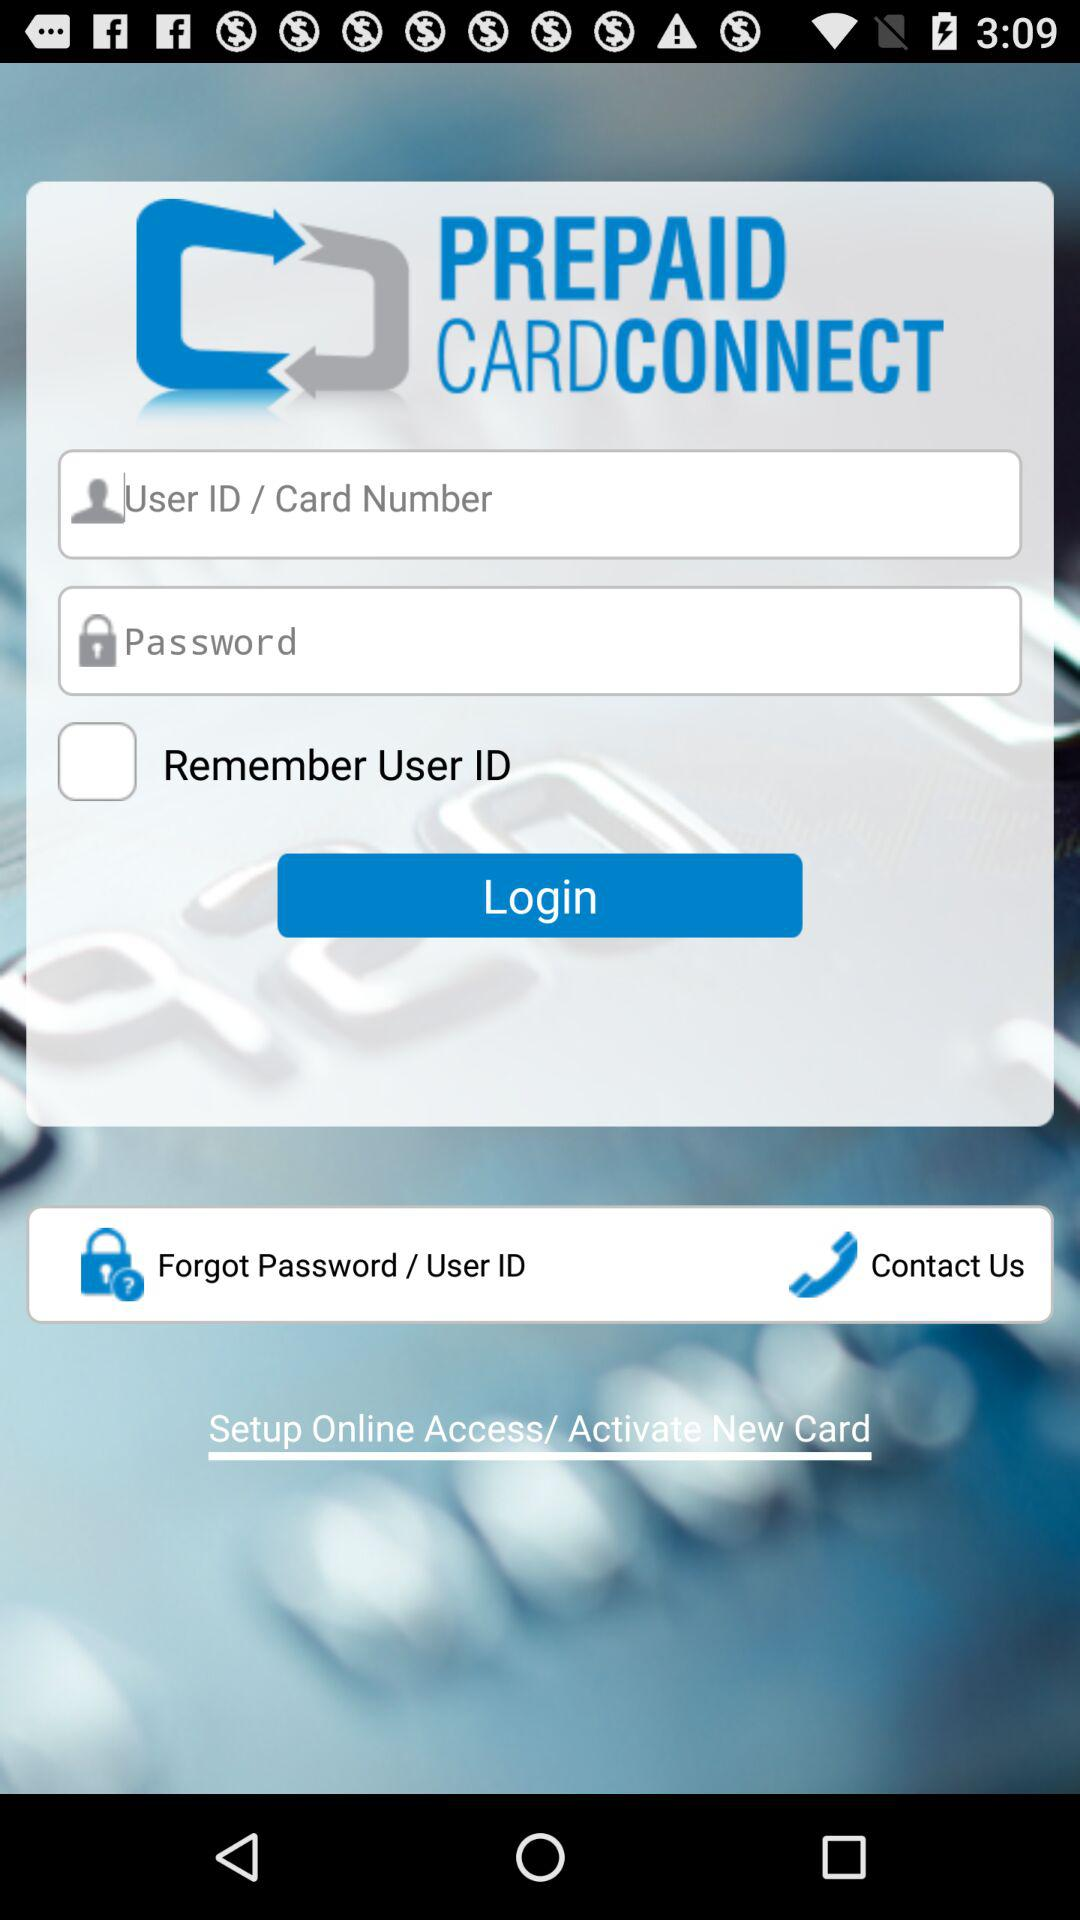How many text inputs are there for entering user information?
Answer the question using a single word or phrase. 2 